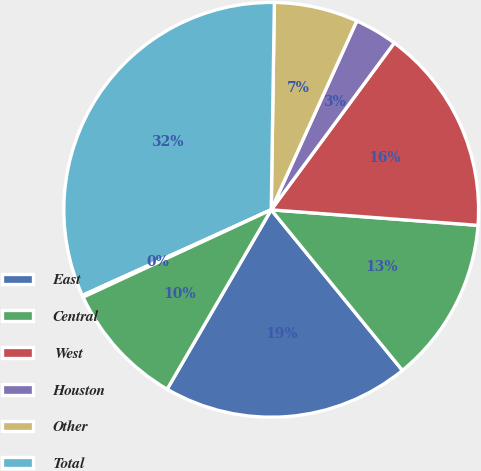Convert chart. <chart><loc_0><loc_0><loc_500><loc_500><pie_chart><fcel>East<fcel>Central<fcel>West<fcel>Houston<fcel>Other<fcel>Total<fcel>Other (1)<fcel>West Houston<nl><fcel>19.27%<fcel>12.9%<fcel>16.08%<fcel>3.34%<fcel>6.53%<fcel>32.01%<fcel>0.15%<fcel>9.71%<nl></chart> 